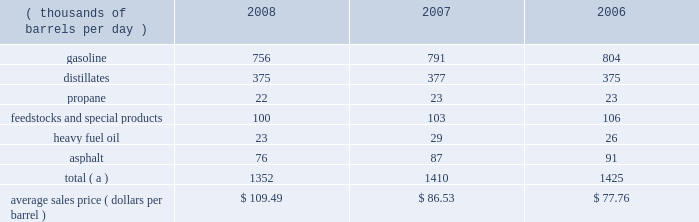The table sets forth our refined products sales by product group and our average sales price for each of the last three years .
Refined product sales ( thousands of barrels per day ) 2008 2007 2006 .
Total ( a ) 1352 1410 1425 average sales price ( dollars per barrel ) $ 109.49 $ 86.53 $ 77.76 ( a ) includes matching buy/sell volumes of 24 mbpd in 2006 .
On april 1 , 2006 , we changed our accounting for matching buy/sell arrangements as a result of a new accounting standard .
This change resulted in lower refined products sales volumes for 2008 , 2007 and the remainder of 2006 than would have been reported under our previous accounting practices .
See note 2 to the consolidated financial statements .
Gasoline and distillates 2013 we sell gasoline , gasoline blendstocks and no .
1 and no .
2 fuel oils ( including kerosene , jet fuel , diesel fuel and home heating oil ) to wholesale marketing customers in the midwest , upper great plains , gulf coast and southeastern regions of the united states .
We sold 47 percent of our gasoline volumes and 88 percent of our distillates volumes on a wholesale or spot market basis in 2008 .
The demand for gasoline is seasonal in many of our markets , with demand typically being at its highest levels during the summer months .
We have blended fuel ethanol into gasoline for over 15 years and began increasing our blending program in 2007 , in part due to federal regulations that require us to use specified volumes of renewable fuels .
We blended 57 mbpd of ethanol into gasoline in 2008 , 41 mbpd in 2007 and 35 mbpd in 2006 .
The future expansion or contraction of our ethanol blending program will be driven by the economics of the ethanol supply and by government regulations .
We sell reformulated gasoline , which is also blended with ethanol , in parts of our marketing territory , including : chicago , illinois ; louisville , kentucky ; northern kentucky ; milwaukee , wisconsin and hartford , illinois .
We also sell biodiesel-blended diesel in minnesota , illinois and kentucky .
In 2007 , we acquired a 35 percent interest in an entity which owns and operates a 110-million-gallon-per-year ethanol production facility in clymers , indiana .
We also own a 50 percent interest in an entity which owns a 110-million-gallon-per-year ethanol production facility in greenville , ohio .
The greenville plant began production in february 2008 .
Both of these facilities are managed by a co-owner .
Propane 2013 we produce propane at all seven of our refineries .
Propane is primarily used for home heating and cooking , as a feedstock within the petrochemical industry , for grain drying and as a fuel for trucks and other vehicles .
Our propane sales are typically split evenly between the home heating market and industrial consumers .
Feedstocks and special products 2013 we are a producer and marketer of petrochemicals and specialty products .
Product availability varies by refinery and includes benzene , cumene , dilute naphthalene oil , molten maleic anhydride , molten sulfur , propylene , toluene and xylene .
We market propylene , cumene and sulfur domestically to customers in the chemical industry .
We sell maleic anhydride throughout the united states and canada .
We also have the capacity to produce 1400 tons per day of anode grade coke at our robinson refinery , which is used to make carbon anodes for the aluminum smelting industry , and 2700 tons per day of fuel grade coke at the garyville refinery , which is used for power generation and in miscellaneous industrial applications .
In september 2008 , we shut down our lubes facility in catlettsburg , kentucky , and sold from inventory through december 31 , 2008 ; therefore , base oils , aromatic extracts and slack wax are no longer being produced and marketed .
In addition , we have recently discontinued production and sales of petroleum pitch and aliphatic solvents .
Heavy fuel oil 2013 we produce and market heavy oil , also known as fuel oil , residual fuel or slurry at all seven of our refineries .
Another product of crude oil , heavy oil is primarily used in the utility and ship bunkering ( fuel ) industries , though there are other more specialized uses of the product .
We also sell heavy fuel oil at our terminals in wellsville , ohio , and chattanooga , tennessee .
Asphalt 2013 we have refinery based asphalt production capacity of up to 102 mbpd .
We market asphalt through 33 owned or leased terminals throughout the midwest and southeast .
We have a broad customer base , including .
For the three year period what was the largest gasoline production in thousand bbl per day? 
Computations: table_max(gasoline, none)
Answer: 804.0. 